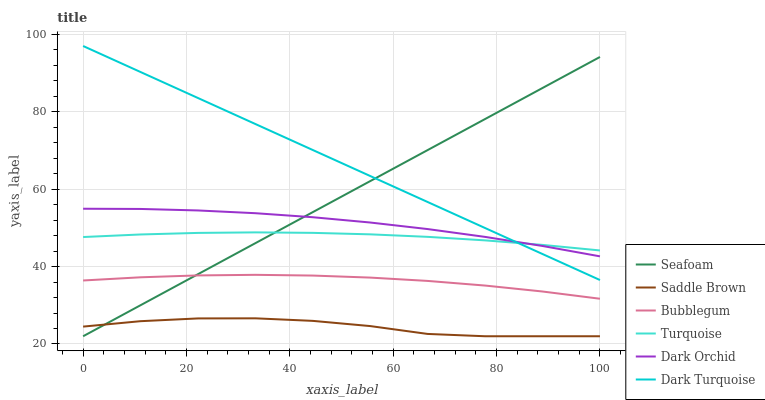Does Saddle Brown have the minimum area under the curve?
Answer yes or no. Yes. Does Dark Turquoise have the maximum area under the curve?
Answer yes or no. Yes. Does Seafoam have the minimum area under the curve?
Answer yes or no. No. Does Seafoam have the maximum area under the curve?
Answer yes or no. No. Is Dark Turquoise the smoothest?
Answer yes or no. Yes. Is Saddle Brown the roughest?
Answer yes or no. Yes. Is Seafoam the smoothest?
Answer yes or no. No. Is Seafoam the roughest?
Answer yes or no. No. Does Seafoam have the lowest value?
Answer yes or no. Yes. Does Dark Turquoise have the lowest value?
Answer yes or no. No. Does Dark Turquoise have the highest value?
Answer yes or no. Yes. Does Seafoam have the highest value?
Answer yes or no. No. Is Saddle Brown less than Dark Orchid?
Answer yes or no. Yes. Is Turquoise greater than Bubblegum?
Answer yes or no. Yes. Does Seafoam intersect Bubblegum?
Answer yes or no. Yes. Is Seafoam less than Bubblegum?
Answer yes or no. No. Is Seafoam greater than Bubblegum?
Answer yes or no. No. Does Saddle Brown intersect Dark Orchid?
Answer yes or no. No. 